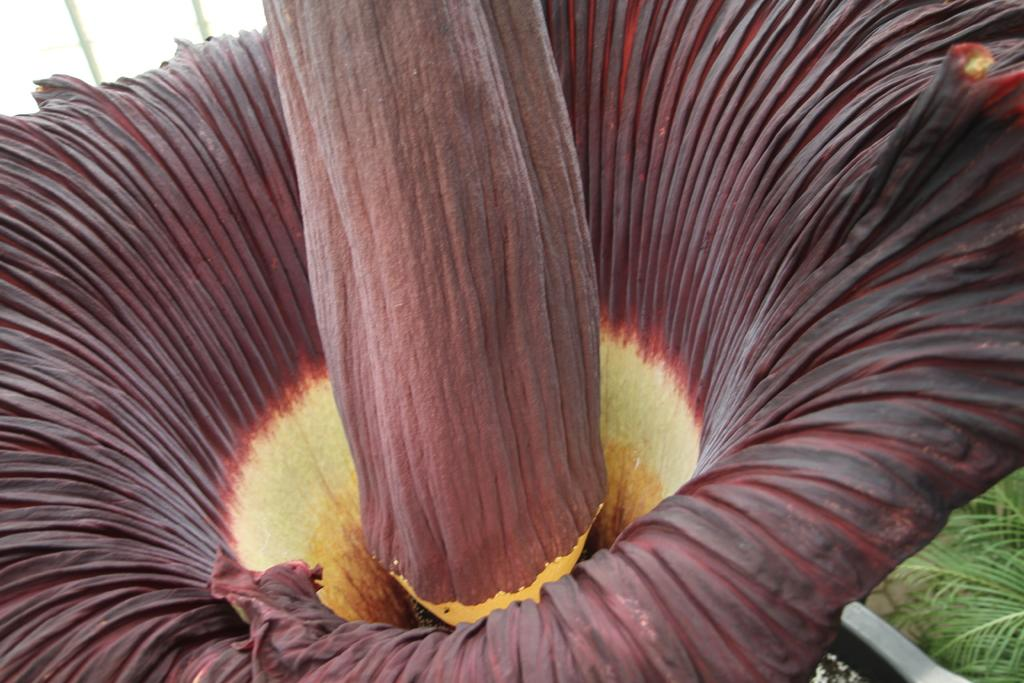What type of flower can be seen in the image? There is a maroon color flower in the image. Can you describe the background of the image? There is a plant in the background of the image. What is the best sidewalk route to take to reach the flower in the image? There is no sidewalk or route mentioned in the image, as it only features a maroon color flower and a plant in the background. 